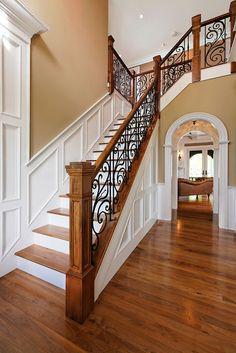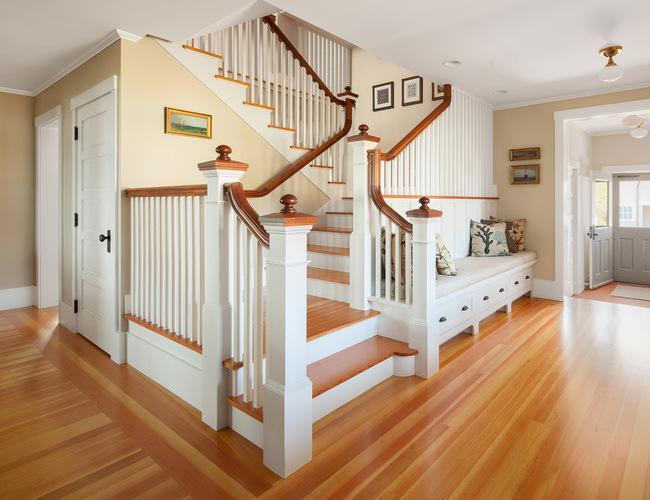The first image is the image on the left, the second image is the image on the right. Analyze the images presented: Is the assertion "The left image shows a staircase that ascends rightward before turning and has black wrought iron rails with scroll shapes." valid? Answer yes or no. Yes. The first image is the image on the left, the second image is the image on the right. Considering the images on both sides, is "At least one stairway has white side railings." valid? Answer yes or no. Yes. 